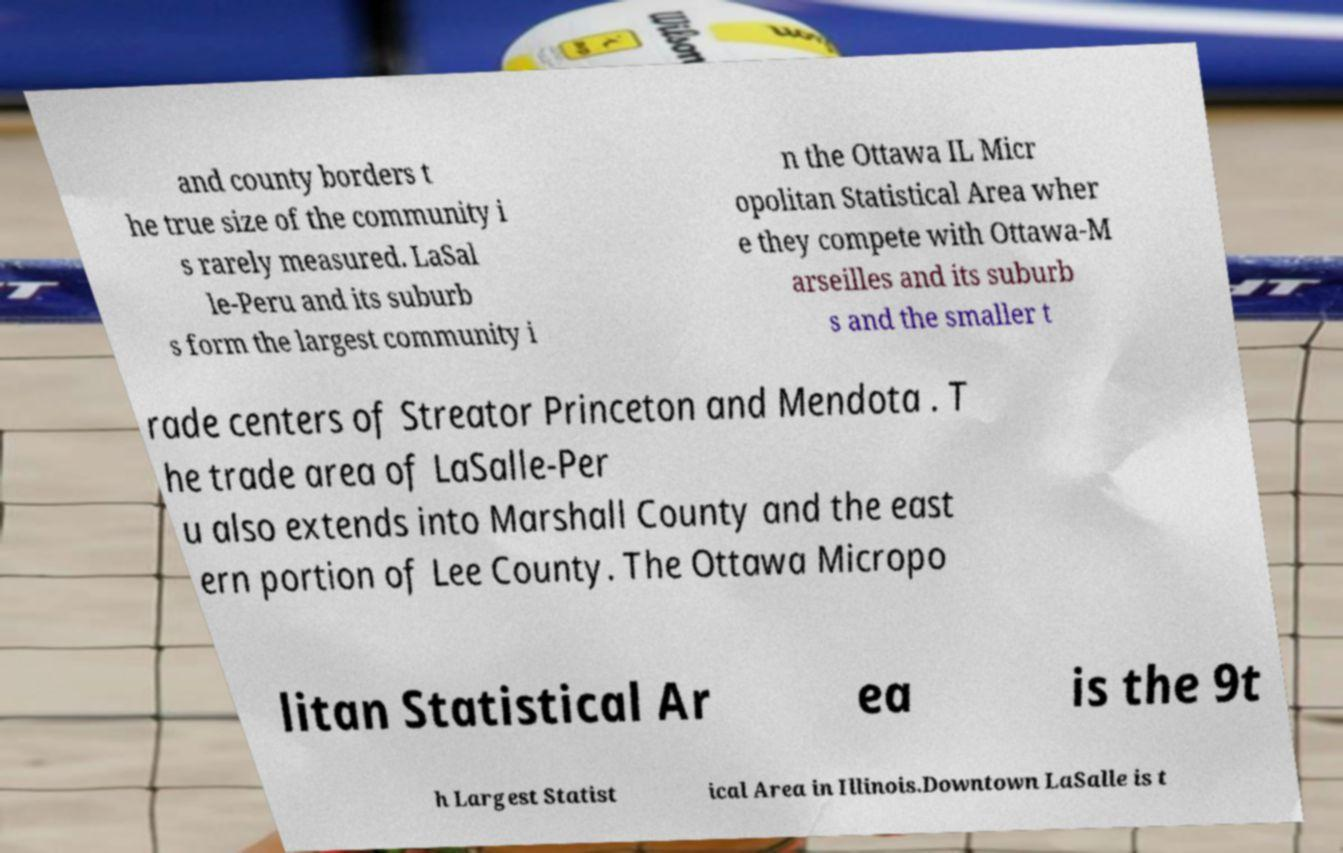Could you extract and type out the text from this image? and county borders t he true size of the community i s rarely measured. LaSal le-Peru and its suburb s form the largest community i n the Ottawa IL Micr opolitan Statistical Area wher e they compete with Ottawa-M arseilles and its suburb s and the smaller t rade centers of Streator Princeton and Mendota . T he trade area of LaSalle-Per u also extends into Marshall County and the east ern portion of Lee County. The Ottawa Micropo litan Statistical Ar ea is the 9t h Largest Statist ical Area in Illinois.Downtown LaSalle is t 